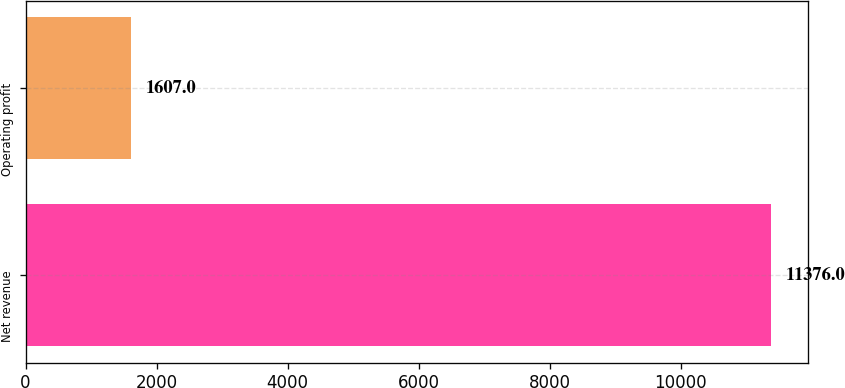<chart> <loc_0><loc_0><loc_500><loc_500><bar_chart><fcel>Net revenue<fcel>Operating profit<nl><fcel>11376<fcel>1607<nl></chart> 